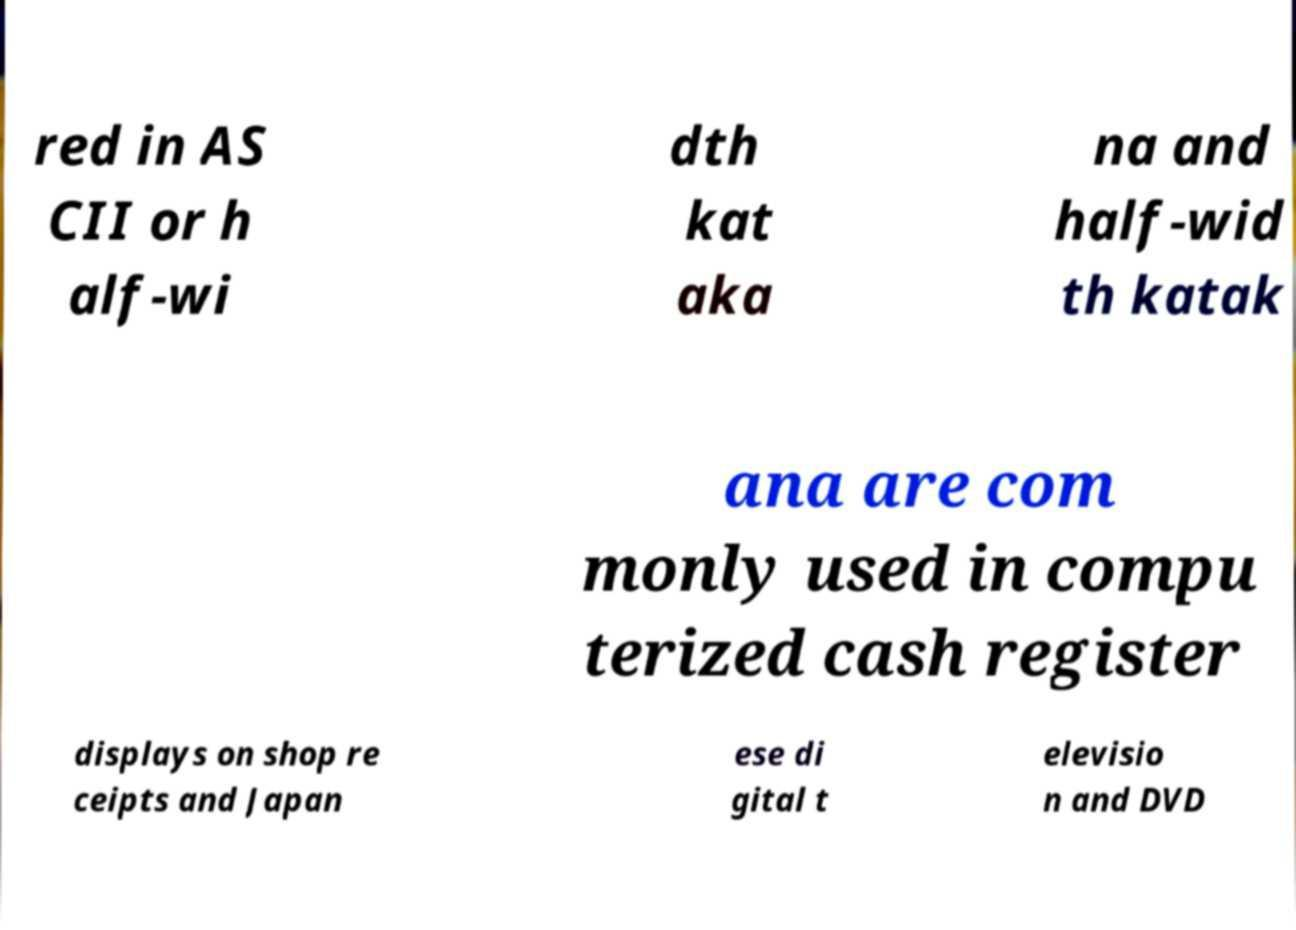Could you extract and type out the text from this image? red in AS CII or h alf-wi dth kat aka na and half-wid th katak ana are com monly used in compu terized cash register displays on shop re ceipts and Japan ese di gital t elevisio n and DVD 